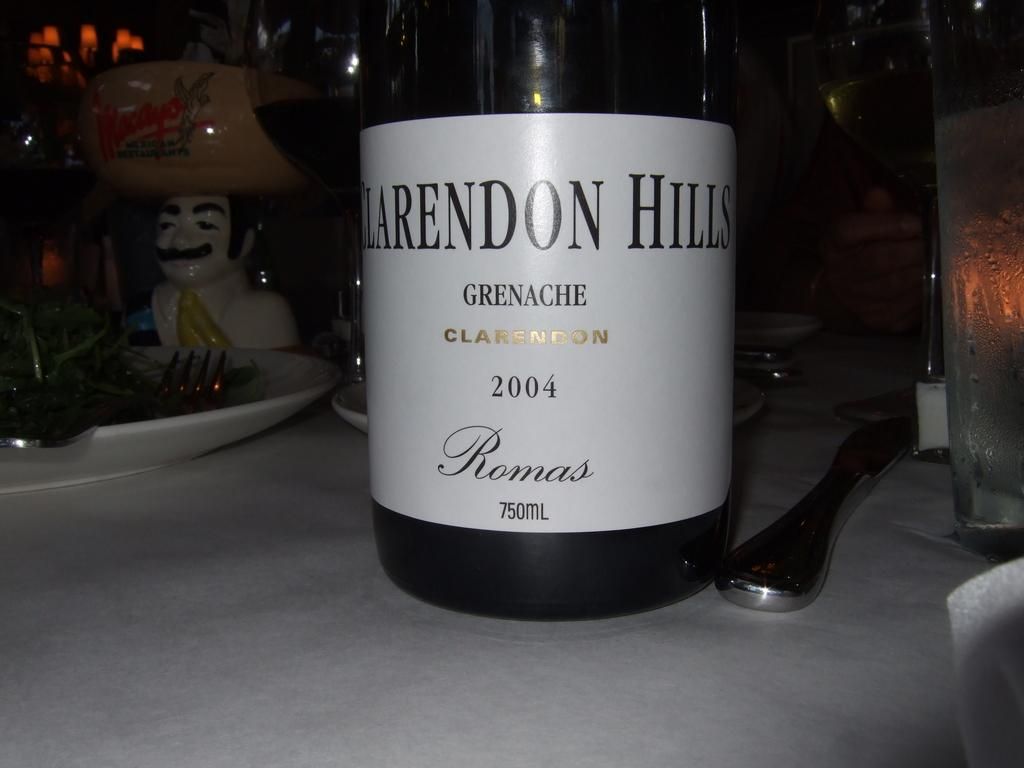Provide a one-sentence caption for the provided image. A Bottle of Clarendon Hills from Romas brand tagged year 2004 on a table. 